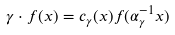<formula> <loc_0><loc_0><loc_500><loc_500>\gamma \cdot f ( x ) = c _ { \gamma } ( x ) f ( \alpha _ { \gamma } ^ { - 1 } x )</formula> 